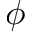<formula> <loc_0><loc_0><loc_500><loc_500>\phi</formula> 